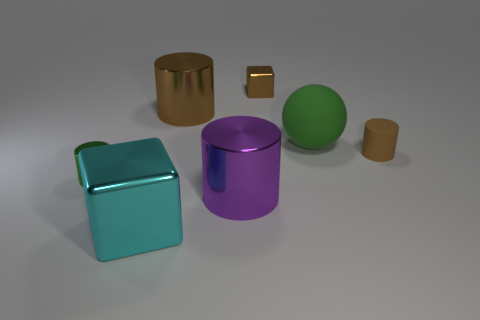Is there anything else that has the same color as the large cube?
Provide a succinct answer. No. Are there any other small shiny things that have the same shape as the cyan metal thing?
Provide a short and direct response. Yes. What color is the other cylinder that is the same size as the green cylinder?
Ensure brevity in your answer.  Brown. How many objects are small cylinders left of the big purple object or things that are in front of the green matte sphere?
Your answer should be very brief. 4. What number of things are green metallic cylinders or rubber cylinders?
Provide a succinct answer. 2. There is a brown object that is right of the large purple metal thing and on the left side of the small brown cylinder; what is its size?
Give a very brief answer. Small. What number of brown cylinders are the same material as the large purple cylinder?
Your answer should be compact. 1. There is another block that is the same material as the cyan block; what color is it?
Provide a short and direct response. Brown. There is a large object on the right side of the purple shiny thing; does it have the same color as the small metallic cylinder?
Provide a short and direct response. Yes. There is a cube that is in front of the small brown metal thing; what is its material?
Provide a succinct answer. Metal. 